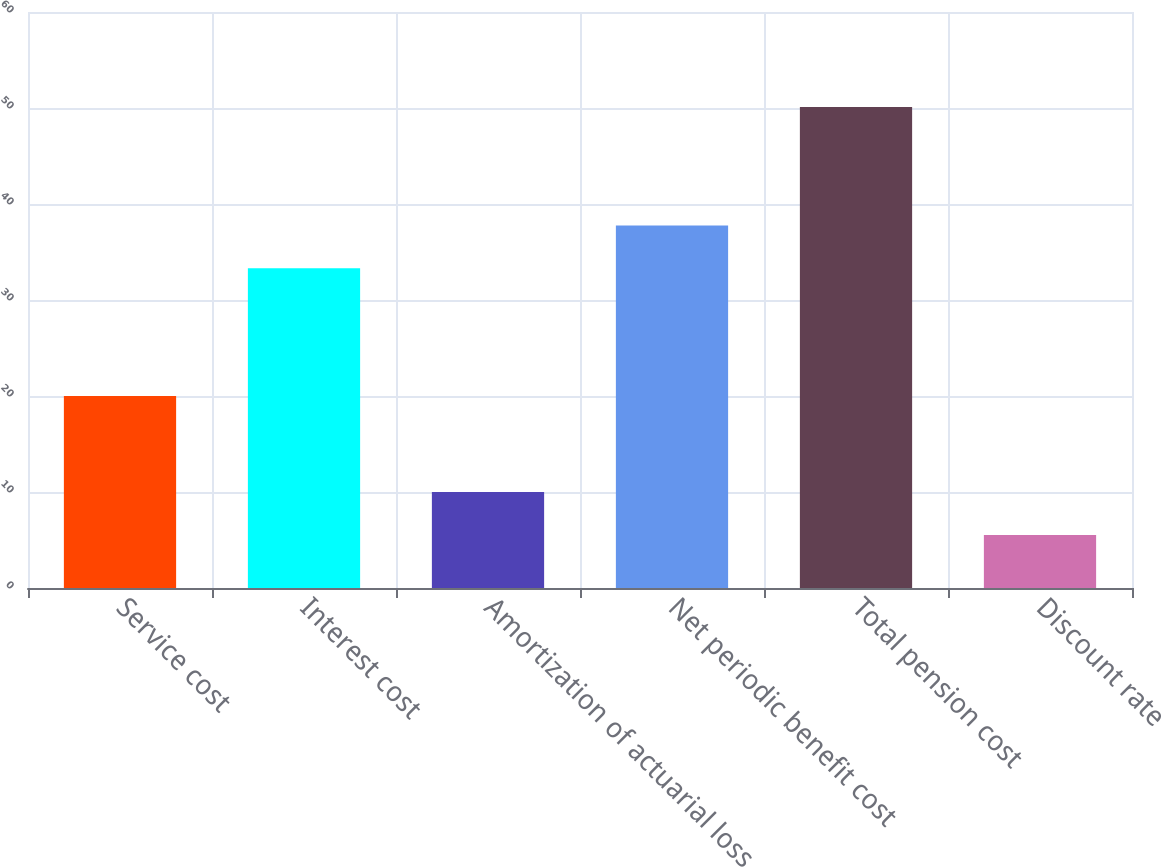Convert chart to OTSL. <chart><loc_0><loc_0><loc_500><loc_500><bar_chart><fcel>Service cost<fcel>Interest cost<fcel>Amortization of actuarial loss<fcel>Net periodic benefit cost<fcel>Total pension cost<fcel>Discount rate<nl><fcel>20<fcel>33.3<fcel>9.99<fcel>37.76<fcel>50.1<fcel>5.53<nl></chart> 